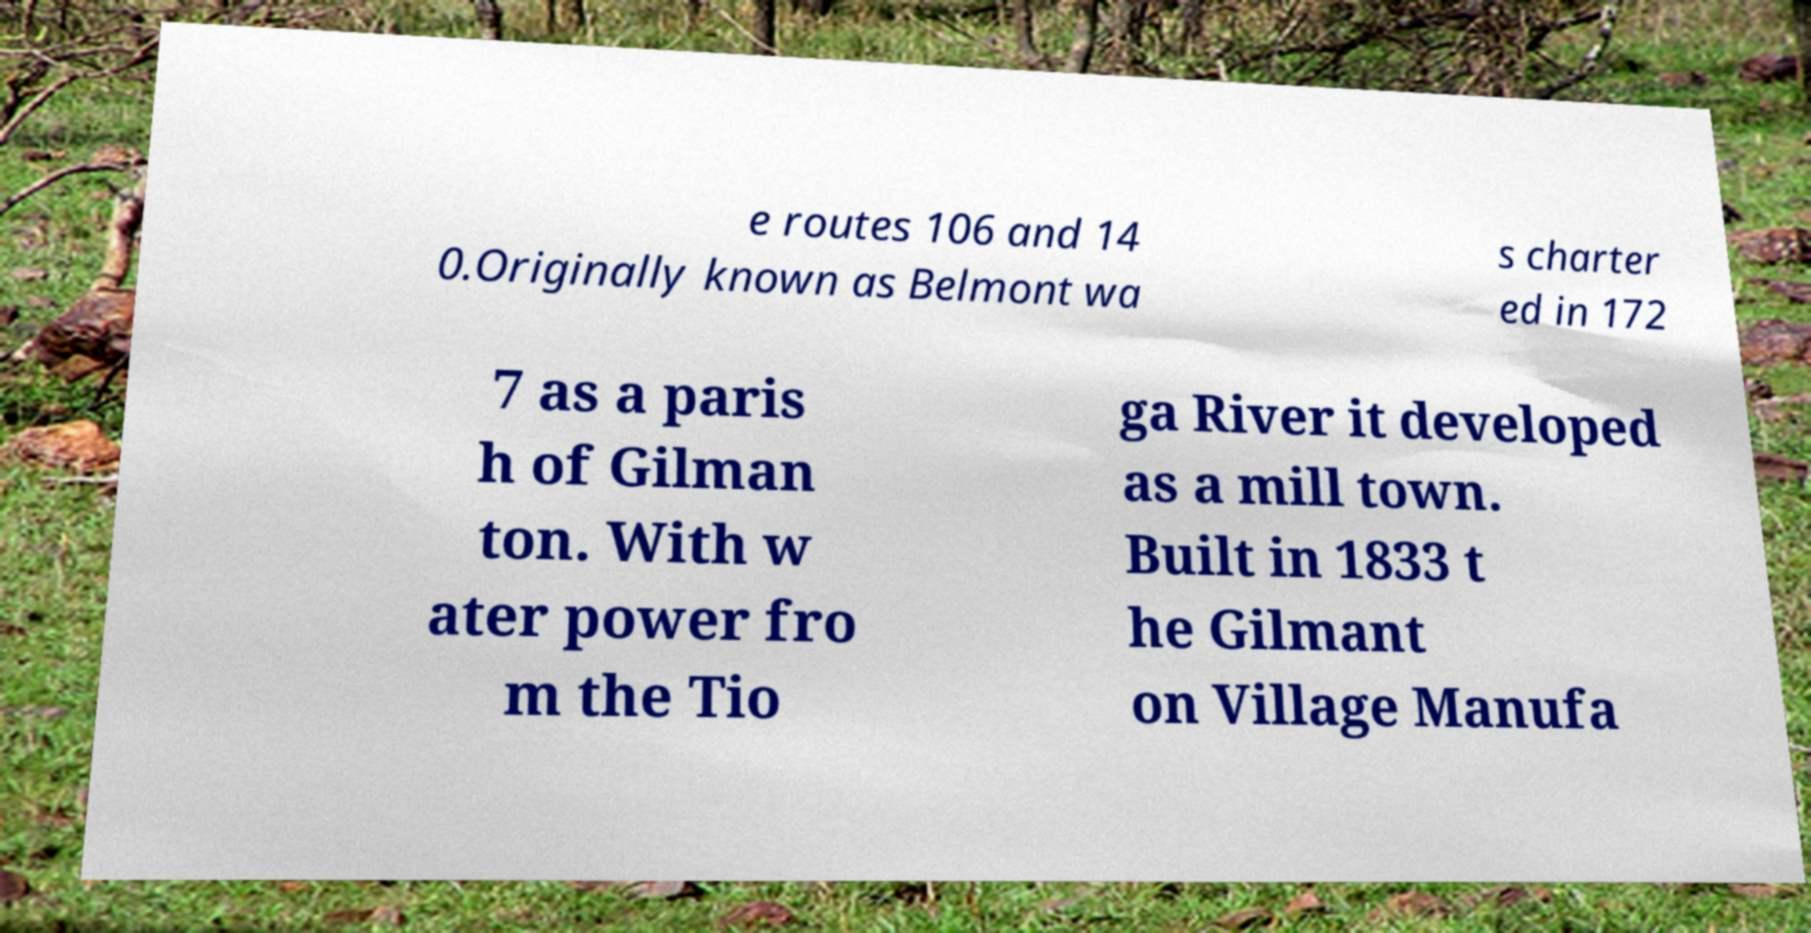I need the written content from this picture converted into text. Can you do that? e routes 106 and 14 0.Originally known as Belmont wa s charter ed in 172 7 as a paris h of Gilman ton. With w ater power fro m the Tio ga River it developed as a mill town. Built in 1833 t he Gilmant on Village Manufa 